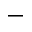Convert formula to latex. <formula><loc_0><loc_0><loc_500><loc_500>-</formula> 